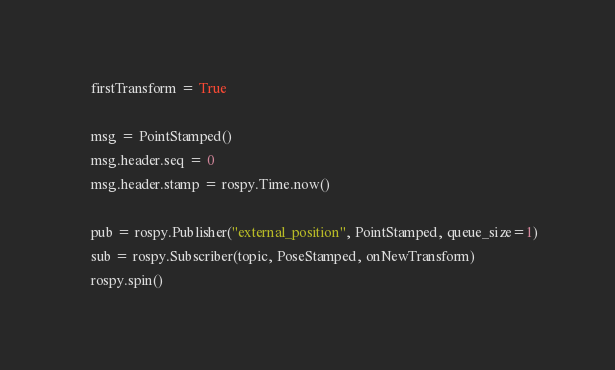Convert code to text. <code><loc_0><loc_0><loc_500><loc_500><_Python_>
    firstTransform = True

    msg = PointStamped()
    msg.header.seq = 0
    msg.header.stamp = rospy.Time.now()

    pub = rospy.Publisher("external_position", PointStamped, queue_size=1)
    sub = rospy.Subscriber(topic, PoseStamped, onNewTransform)
    rospy.spin()
</code> 